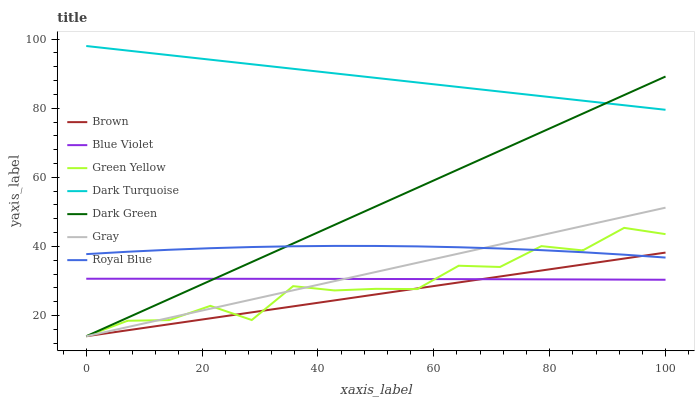Does Brown have the minimum area under the curve?
Answer yes or no. Yes. Does Dark Turquoise have the maximum area under the curve?
Answer yes or no. Yes. Does Gray have the minimum area under the curve?
Answer yes or no. No. Does Gray have the maximum area under the curve?
Answer yes or no. No. Is Gray the smoothest?
Answer yes or no. Yes. Is Green Yellow the roughest?
Answer yes or no. Yes. Is Dark Turquoise the smoothest?
Answer yes or no. No. Is Dark Turquoise the roughest?
Answer yes or no. No. Does Brown have the lowest value?
Answer yes or no. Yes. Does Dark Turquoise have the lowest value?
Answer yes or no. No. Does Dark Turquoise have the highest value?
Answer yes or no. Yes. Does Gray have the highest value?
Answer yes or no. No. Is Green Yellow less than Dark Turquoise?
Answer yes or no. Yes. Is Dark Turquoise greater than Brown?
Answer yes or no. Yes. Does Royal Blue intersect Gray?
Answer yes or no. Yes. Is Royal Blue less than Gray?
Answer yes or no. No. Is Royal Blue greater than Gray?
Answer yes or no. No. Does Green Yellow intersect Dark Turquoise?
Answer yes or no. No. 